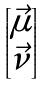<formula> <loc_0><loc_0><loc_500><loc_500>\begin{bmatrix} \vec { \mu } \\ \vec { \nu } \end{bmatrix}</formula> 